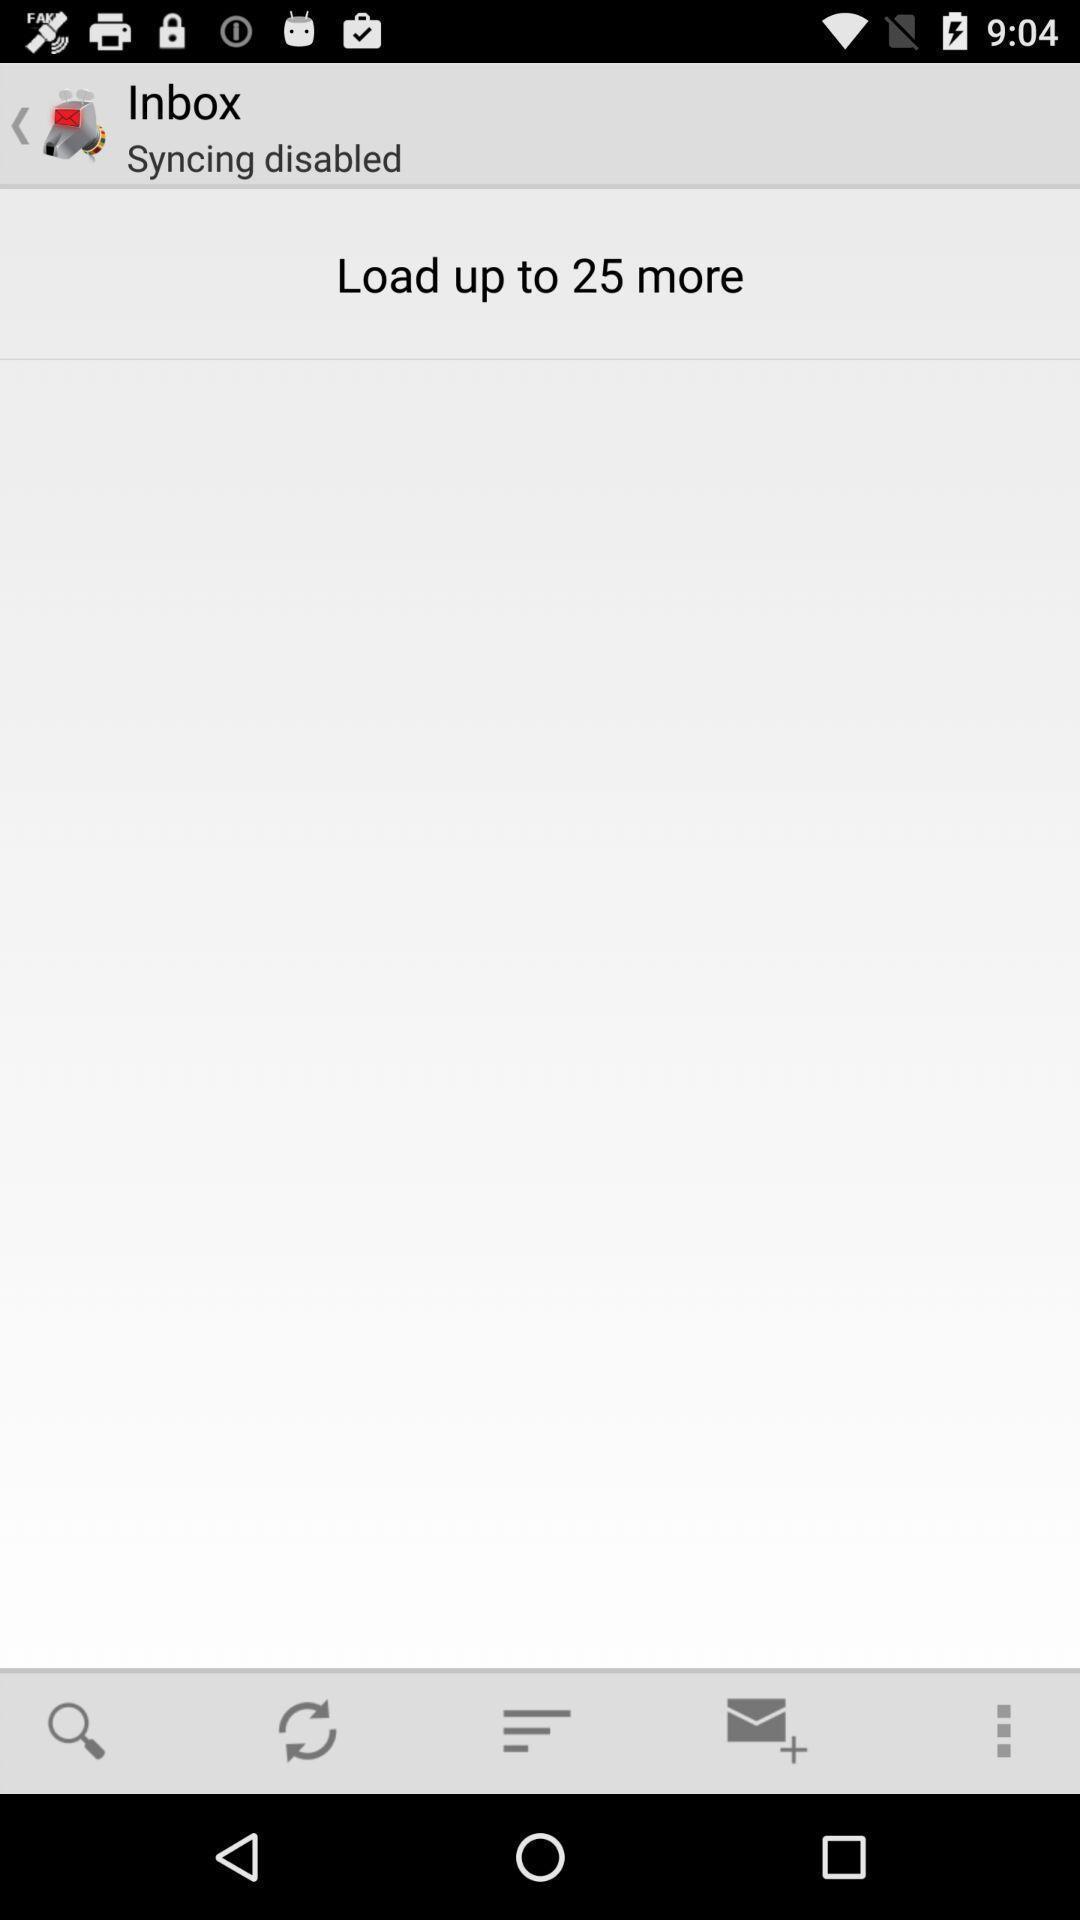Provide a detailed account of this screenshot. Page displaying inbox. 